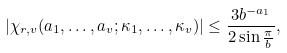<formula> <loc_0><loc_0><loc_500><loc_500>| \chi _ { r , v } ( a _ { 1 } , \dots , a _ { v } ; \kappa _ { 1 } , \dots , \kappa _ { v } ) | \leq \frac { 3 b ^ { - a _ { 1 } } } { 2 \sin \frac { \pi } { b } } ,</formula> 